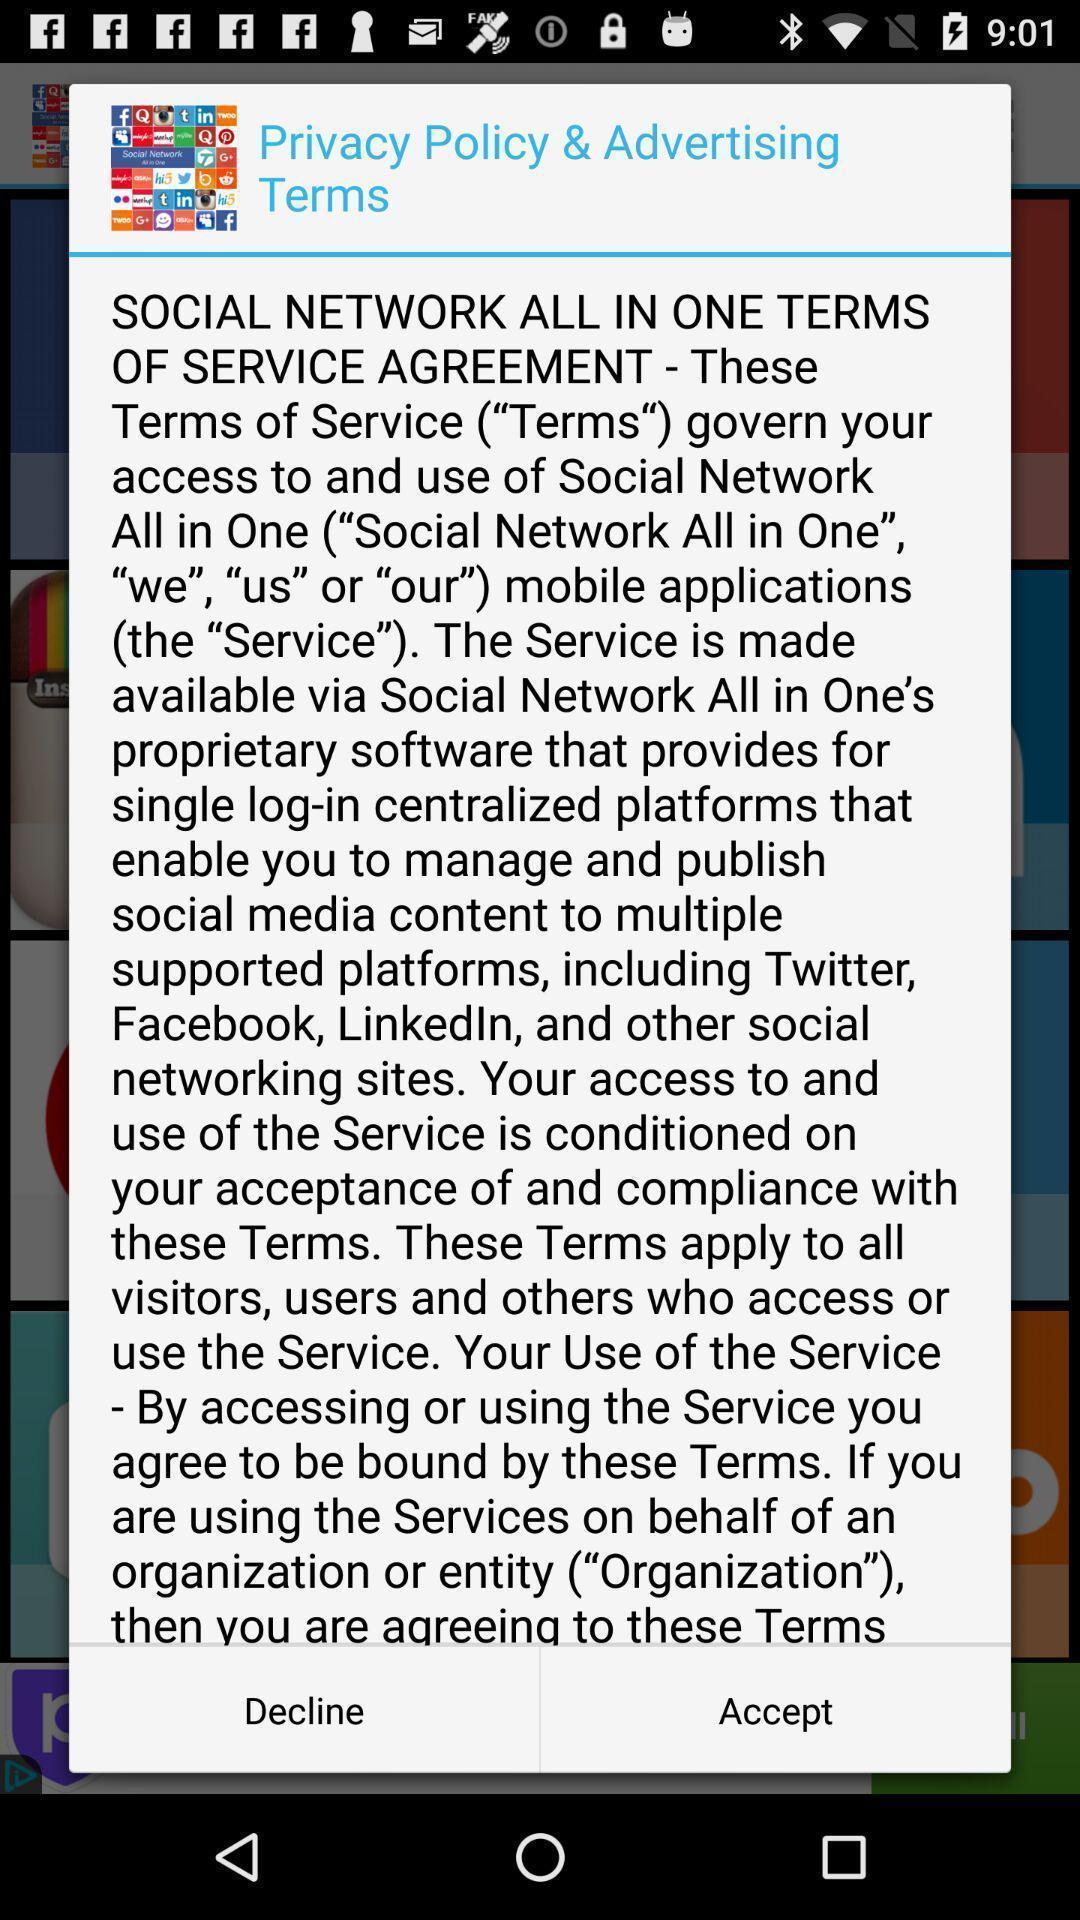Give me a narrative description of this picture. Terms to manage social networks. 